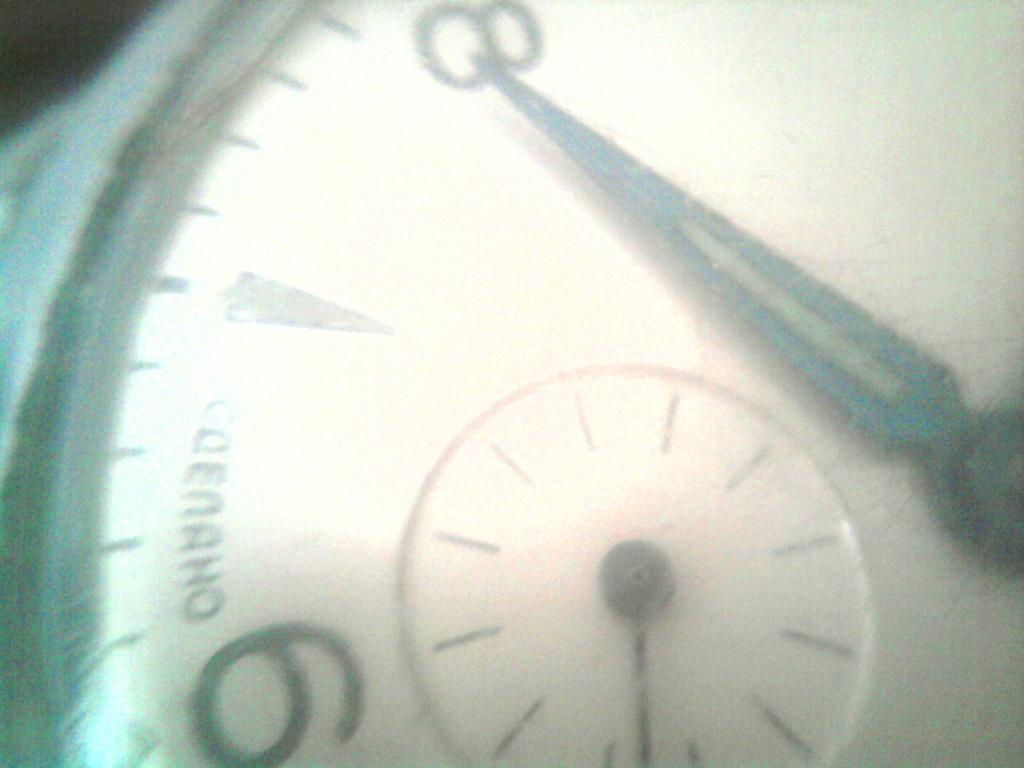<image>
Give a short and clear explanation of the subsequent image. A close up of a watch face with a hand pointing to the number 8. 